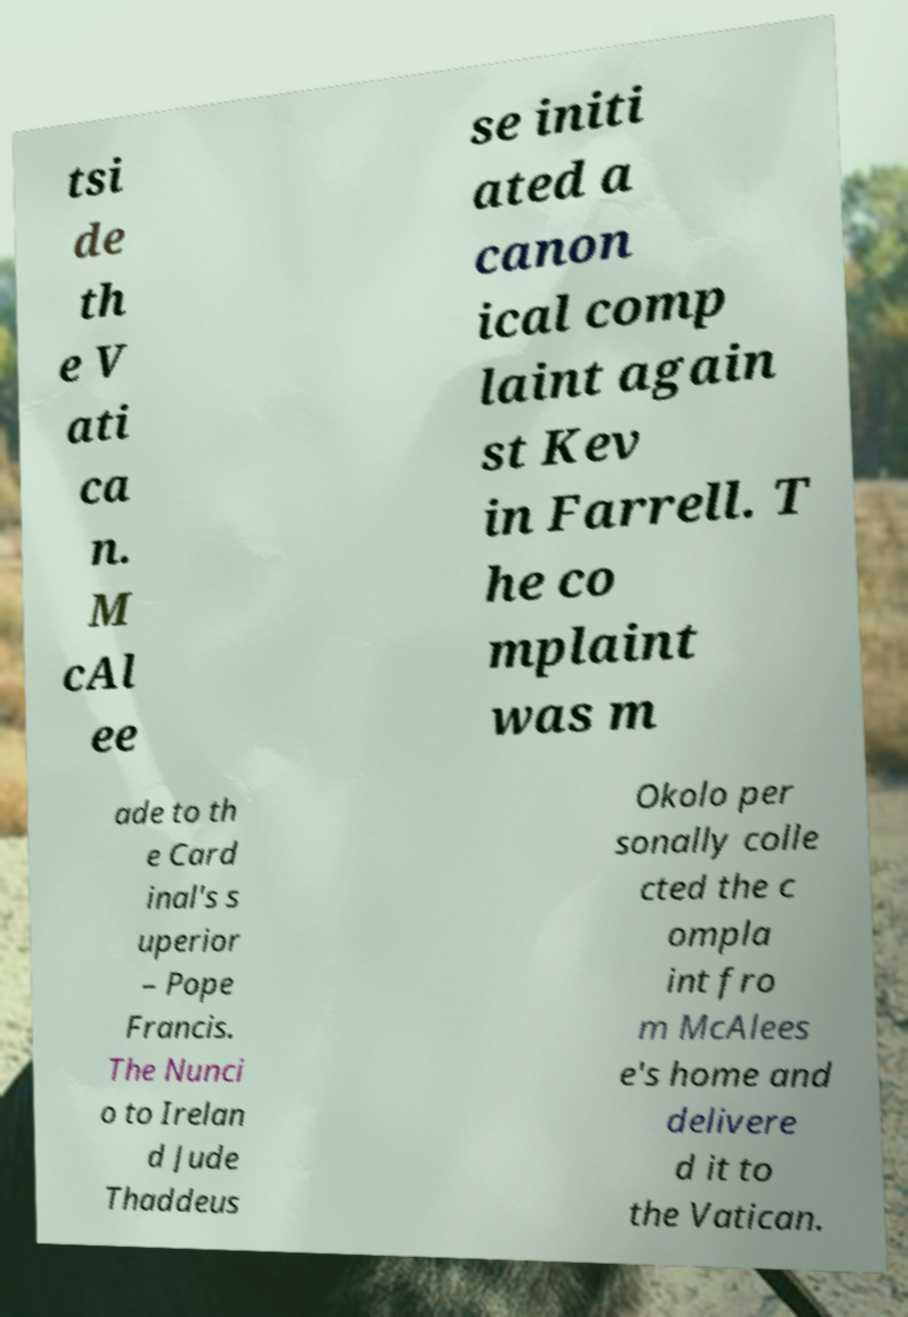Please read and relay the text visible in this image. What does it say? tsi de th e V ati ca n. M cAl ee se initi ated a canon ical comp laint again st Kev in Farrell. T he co mplaint was m ade to th e Card inal's s uperior – Pope Francis. The Nunci o to Irelan d Jude Thaddeus Okolo per sonally colle cted the c ompla int fro m McAlees e's home and delivere d it to the Vatican. 